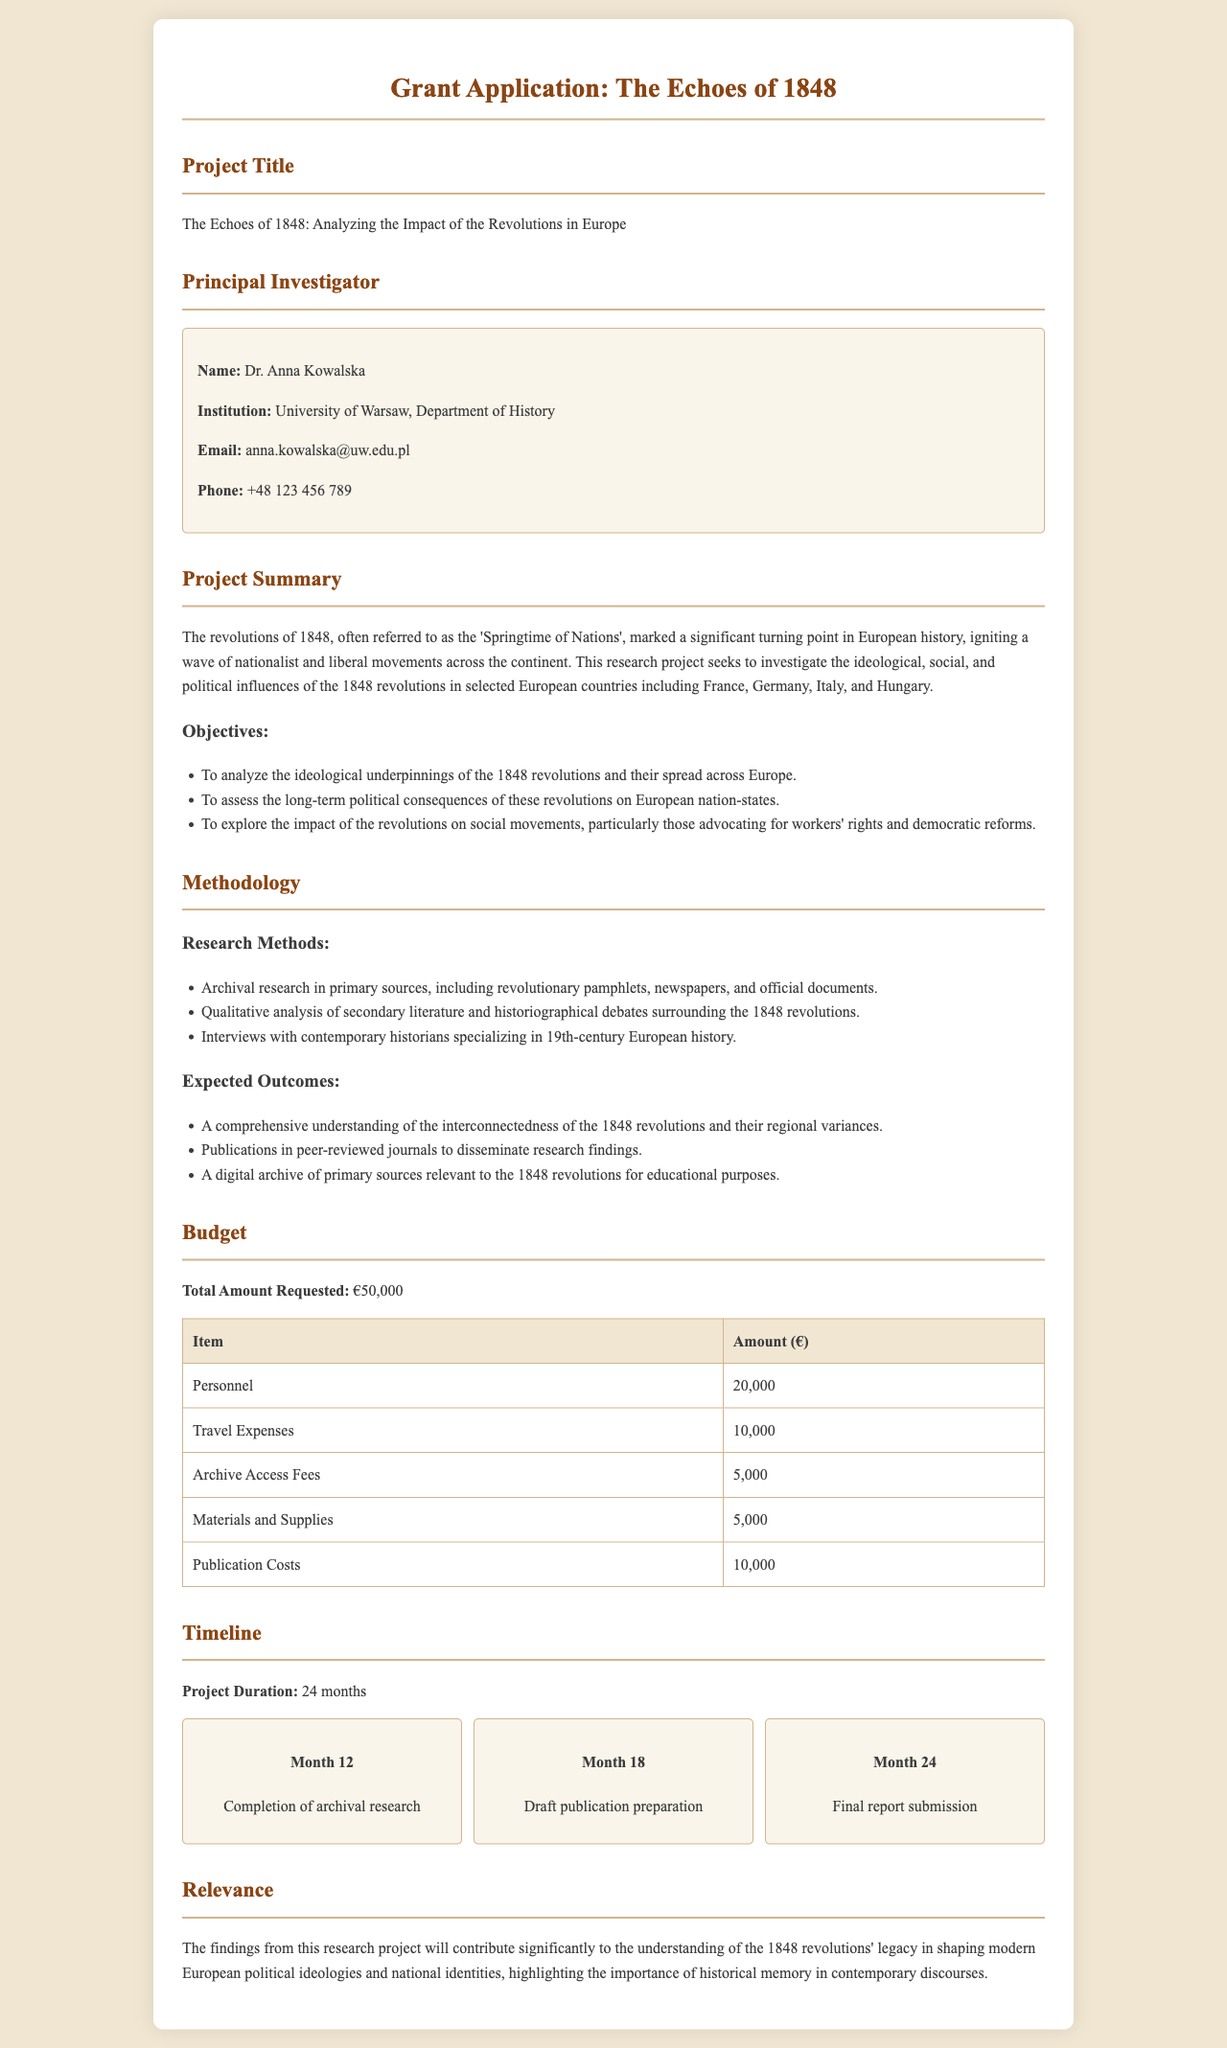what is the project title? The project title is explicitly mentioned in the document under the relevant section.
Answer: The Echoes of 1848: Analyzing the Impact of the Revolutions in Europe who is the principal investigator? The name of the principal investigator is provided in the document, detailing their identity.
Answer: Dr. Anna Kowalska what is the total amount requested for the project? The total amount requested is specified in the budget section of the document.
Answer: €50,000 which countries are included in the research project? The document lists specific countries that are the focus of the research project.
Answer: France, Germany, Italy, Hungary what are the expected outcomes listed in the project summary? The expected outcomes are highlighted in a specific section of the document, summarizing what the research hopes to achieve.
Answer: A comprehensive understanding, publications, a digital archive how long will the project last? The duration of the project is outlined prominently in the timeline section of the document.
Answer: 24 months what is the budget item with the highest allocation? The document provides a detailed budget breakdown, indicating which item has the most funding.
Answer: Personnel what milestone is scheduled for month 18? The timeline lists specific milestones along with their corresponding months, including this particular one.
Answer: Draft publication preparation why is this research project relevant? The relevance of the project is explained in a distinct section of the document, emphasizing its significance.
Answer: Understanding the 1848 revolutions’ legacy 